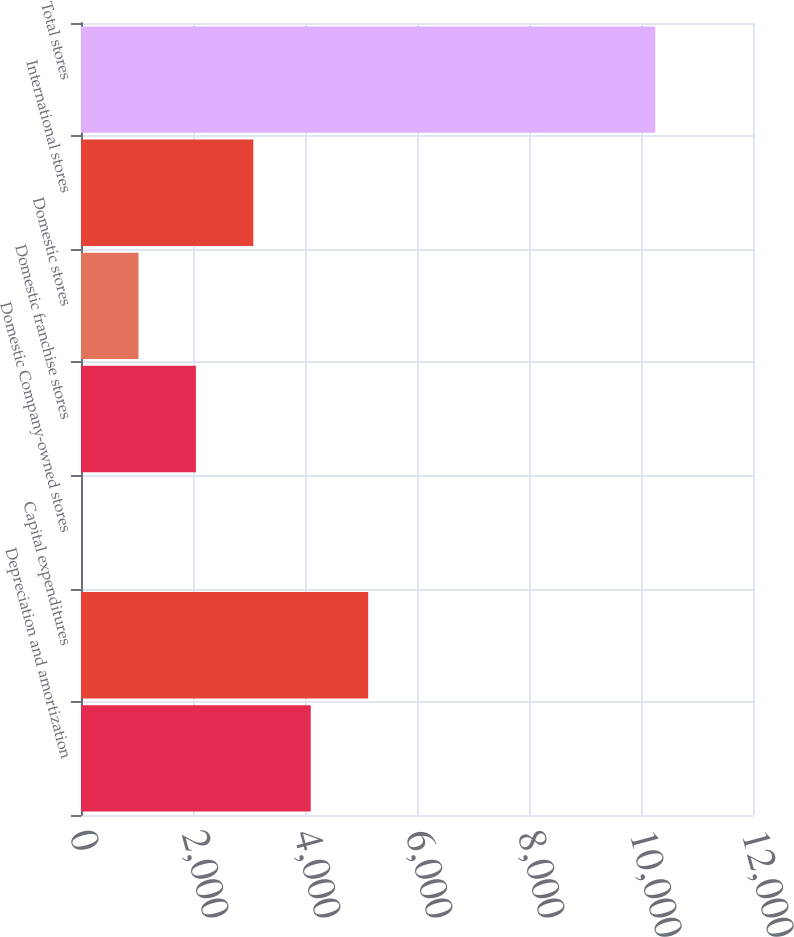Convert chart to OTSL. <chart><loc_0><loc_0><loc_500><loc_500><bar_chart><fcel>Depreciation and amortization<fcel>Capital expenditures<fcel>Domestic Company-owned stores<fcel>Domestic franchise stores<fcel>Domestic stores<fcel>International stores<fcel>Total stores<nl><fcel>4102.78<fcel>5128.15<fcel>1.3<fcel>2052.04<fcel>1026.67<fcel>3077.41<fcel>10255<nl></chart> 